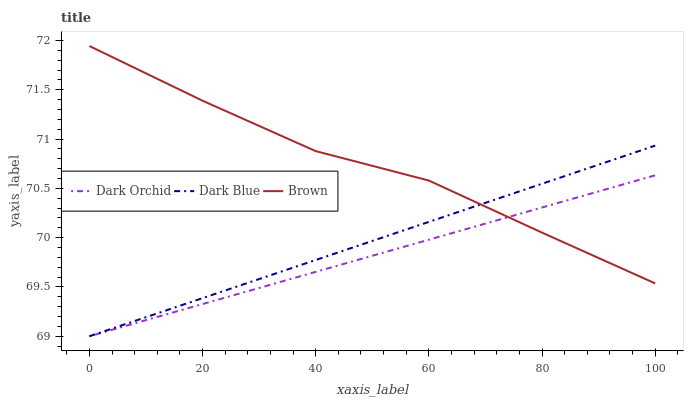Does Dark Orchid have the minimum area under the curve?
Answer yes or no. Yes. Does Brown have the maximum area under the curve?
Answer yes or no. Yes. Does Brown have the minimum area under the curve?
Answer yes or no. No. Does Dark Orchid have the maximum area under the curve?
Answer yes or no. No. Is Dark Orchid the smoothest?
Answer yes or no. Yes. Is Brown the roughest?
Answer yes or no. Yes. Is Brown the smoothest?
Answer yes or no. No. Is Dark Orchid the roughest?
Answer yes or no. No. Does Dark Blue have the lowest value?
Answer yes or no. Yes. Does Brown have the lowest value?
Answer yes or no. No. Does Brown have the highest value?
Answer yes or no. Yes. Does Dark Orchid have the highest value?
Answer yes or no. No. Does Dark Blue intersect Brown?
Answer yes or no. Yes. Is Dark Blue less than Brown?
Answer yes or no. No. Is Dark Blue greater than Brown?
Answer yes or no. No. 